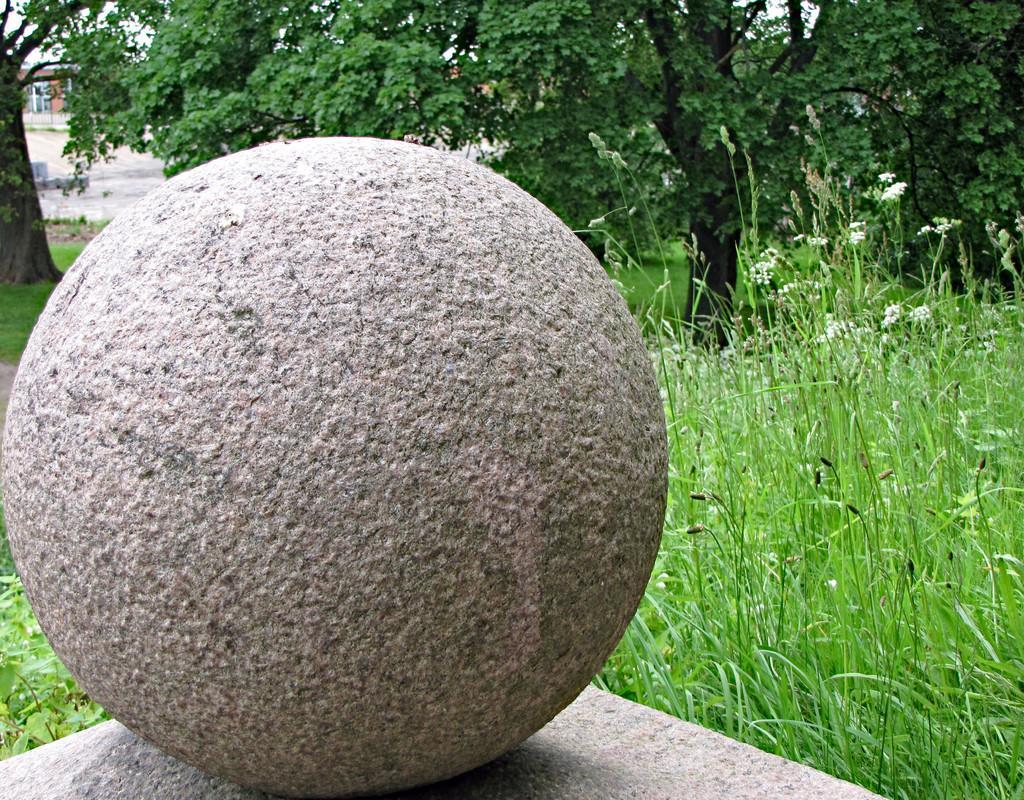How would you summarize this image in a sentence or two? In this picture we can see a round object on an object. We can see some grass, trees and a building in the background. 